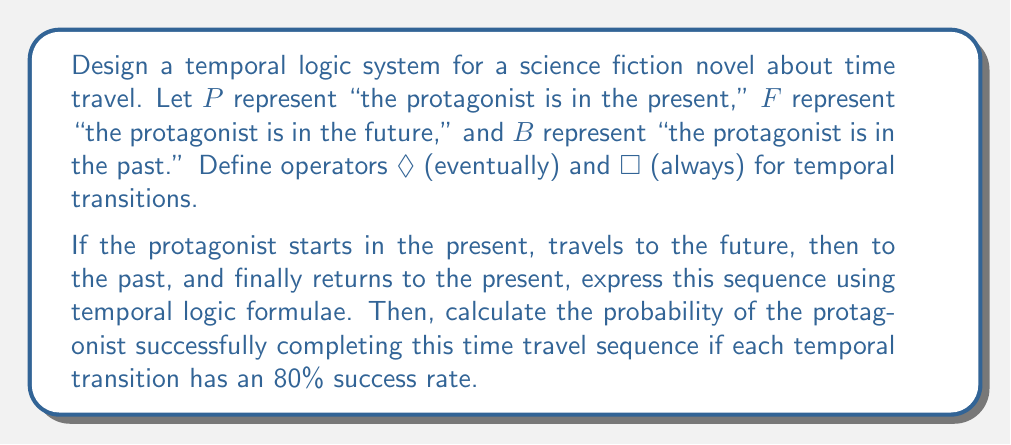Help me with this question. To solve this problem, we'll follow these steps:

1. Express the time travel sequence using temporal logic formulae.
2. Count the number of temporal transitions.
3. Calculate the probability of success for the entire sequence.

Step 1: Expressing the time travel sequence

The sequence can be represented as follows:
$$P \wedge \Diamond(F \wedge \Diamond(B \wedge \Diamond P))$$

This formula reads as: The protagonist is in the present (P) and eventually ($\Diamond$) will be in the future (F), and from there eventually ($\Diamond$) will be in the past (B), and finally will eventually ($\Diamond$) return to the present (P).

Step 2: Counting temporal transitions

In the given sequence, we can identify three temporal transitions:
1. Present to Future
2. Future to Past
3. Past to Present

Step 3: Calculating the probability of success

Given:
- Each temporal transition has an 80% success rate
- There are 3 transitions in total

The probability of success for the entire sequence is the product of the individual probabilities:

$$P(\text{success}) = 0.80 \times 0.80 \times 0.80 = 0.80^3$$

$$P(\text{success}) = 0.512$$

Therefore, the probability of the protagonist successfully completing this time travel sequence is 0.512 or 51.2%.
Answer: The temporal logic formula representing the time travel sequence is:
$$P \wedge \Diamond(F \wedge \Diamond(B \wedge \Diamond P))$$

The probability of successfully completing the entire time travel sequence is 0.512 or 51.2%. 